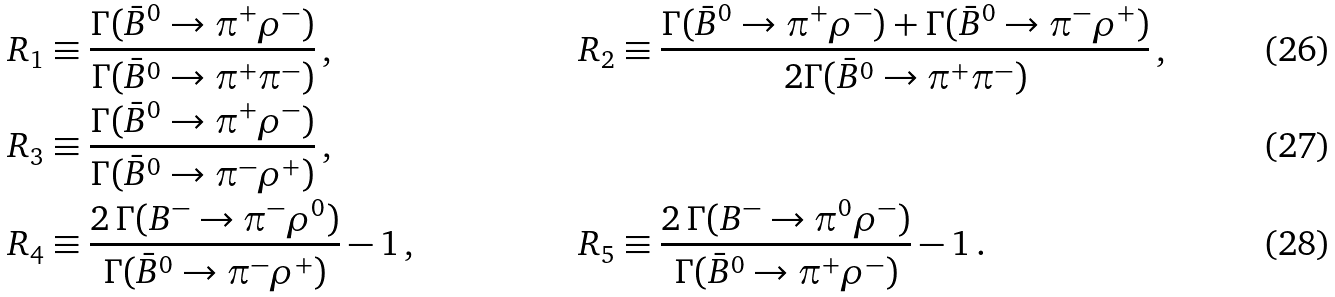Convert formula to latex. <formula><loc_0><loc_0><loc_500><loc_500>R _ { 1 } & \equiv \frac { \Gamma ( \bar { B } ^ { 0 } \to \pi ^ { + } \rho ^ { - } ) } { \Gamma ( \bar { B } ^ { 0 } \to \pi ^ { + } \pi ^ { - } ) } \, , \quad & R _ { 2 } & \equiv \frac { \Gamma ( \bar { B } ^ { 0 } \to \pi ^ { + } \rho ^ { - } ) + \Gamma ( \bar { B } ^ { 0 } \to \pi ^ { - } \rho ^ { + } ) } { 2 \Gamma ( \bar { B } ^ { 0 } \to \pi ^ { + } \pi ^ { - } ) } \, , \\ R _ { 3 } & \equiv \frac { \Gamma ( \bar { B } ^ { 0 } \to \pi ^ { + } \rho ^ { - } ) } { \Gamma ( \bar { B } ^ { 0 } \to \pi ^ { - } \rho ^ { + } ) } \, , & & \\ R _ { 4 } & \equiv \frac { 2 \, \Gamma ( B ^ { - } \to \pi ^ { - } \rho ^ { 0 } ) } { \Gamma ( \bar { B } ^ { 0 } \to \pi ^ { - } \rho ^ { + } ) } - 1 \, , & R _ { 5 } & \equiv \frac { 2 \, \Gamma ( B ^ { - } \to \pi ^ { 0 } \rho ^ { - } ) } { \Gamma ( \bar { B } ^ { 0 } \to \pi ^ { + } \rho ^ { - } ) } - 1 \, .</formula> 